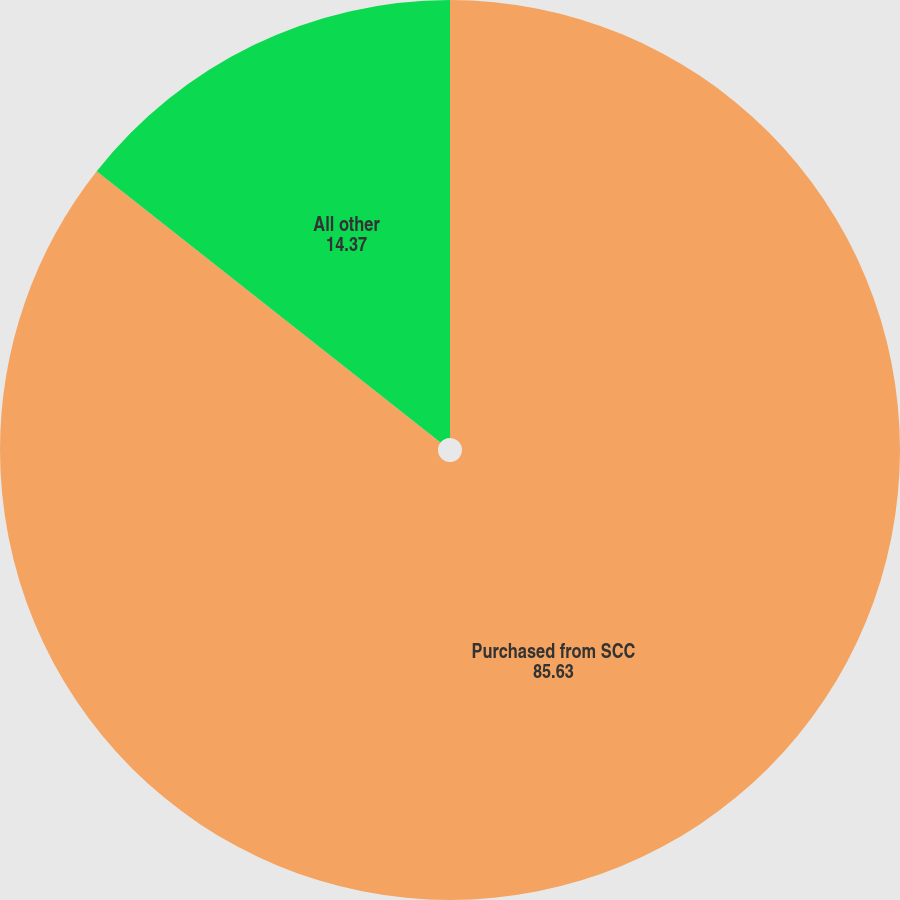<chart> <loc_0><loc_0><loc_500><loc_500><pie_chart><fcel>Purchased from SCC<fcel>All other<nl><fcel>85.63%<fcel>14.37%<nl></chart> 